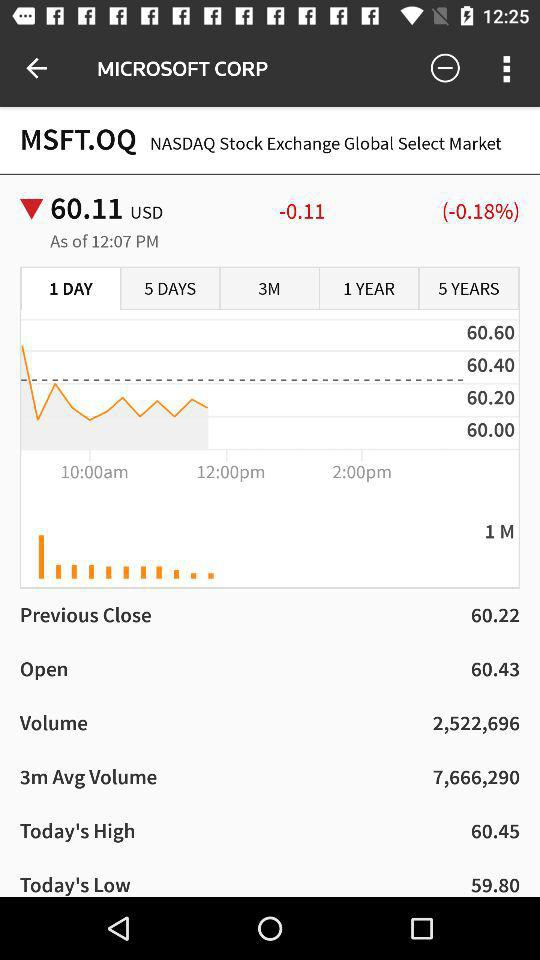How much has the price of MSFT.QQ changed since the previous close?
Answer the question using a single word or phrase. -0.11 